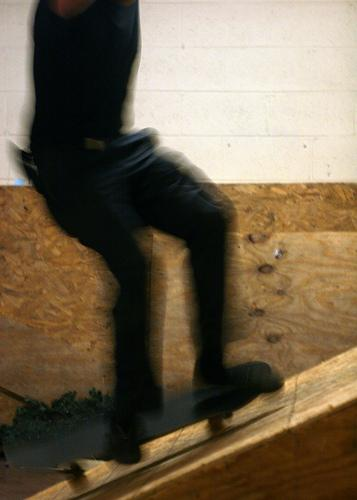Discuss the contrasts in color present within the image. The image features a contrast between the skateboarder's dark clothing and the bright white color of the brick wall, as well as the brown tones of the wooden ramp. Describe the image focusing on the skateboarder's position and the ramp. A man is skillfully positioned on his skateboard while navigating a wooden ramp inside an indoor facility. Provide a general description of the scene in the image. A skateboarder is riding on a wooden ramp inside a facility with white brick walls and various objects around such as benches and tables. Highlight the features of the skate ramp and the surroundings. The skate ramp is made of wood with a few knots and is positioned against a white brick wall with a blue sticker and a wooden side wall. Name some objects and their colors you can find in the image. Skateboard (various), jeans (blue), t-shirt (black), brick wall (white), sticker (blue), wooden ramp and wall (brown), and grass (green). Create a short, catchy caption for the image. Skateboarder in action: Riding the ramp in style! Mention the main elements of the image and their colors. A man in a black t-shirt and blue jeans is skateboarding on a brown wooden ramp, against a white wall with a blue sticker. Describe the man's clothing and accessories visible in the image. The skateboarder is wearing a black short-sleeve t-shirt, blue jeans, black sneakers, and has something in his pocket. What is the overall ambiance of the location where the skateboarder is performing? The ambiance is that of an indoor skate park with white brick walls, a wooden ramp, and a few other amenities. Briefly describe the skateboarder's appearance and what he's doing. A man wearing a dark shirt and jeans is skillfully riding a skateboard on a ramp within a park. 